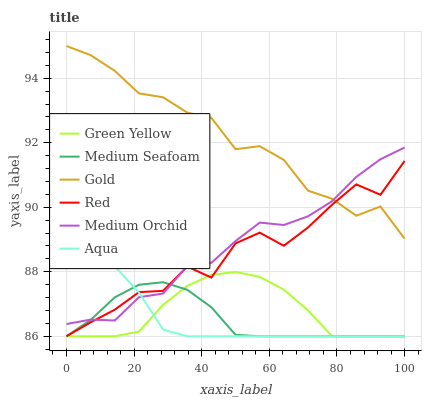Does Medium Seafoam have the minimum area under the curve?
Answer yes or no. Yes. Does Gold have the maximum area under the curve?
Answer yes or no. Yes. Does Medium Orchid have the minimum area under the curve?
Answer yes or no. No. Does Medium Orchid have the maximum area under the curve?
Answer yes or no. No. Is Aqua the smoothest?
Answer yes or no. Yes. Is Red the roughest?
Answer yes or no. Yes. Is Medium Orchid the smoothest?
Answer yes or no. No. Is Medium Orchid the roughest?
Answer yes or no. No. Does Aqua have the lowest value?
Answer yes or no. Yes. Does Medium Orchid have the lowest value?
Answer yes or no. No. Does Gold have the highest value?
Answer yes or no. Yes. Does Medium Orchid have the highest value?
Answer yes or no. No. Is Medium Seafoam less than Gold?
Answer yes or no. Yes. Is Gold greater than Medium Seafoam?
Answer yes or no. Yes. Does Medium Orchid intersect Gold?
Answer yes or no. Yes. Is Medium Orchid less than Gold?
Answer yes or no. No. Is Medium Orchid greater than Gold?
Answer yes or no. No. Does Medium Seafoam intersect Gold?
Answer yes or no. No. 